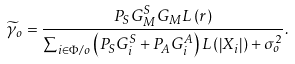Convert formula to latex. <formula><loc_0><loc_0><loc_500><loc_500>{ \widetilde { \gamma } _ { o } } = \frac { { { P _ { S } } G _ { M } ^ { S } G _ { M } L \left ( r \right ) } } { { \sum \nolimits _ { i \in \Phi / o } \left ( P _ { S } G _ { i } ^ { S } + P _ { A } G _ { i } ^ { A } \right ) L \left ( \left | X _ { i } \right | \right ) + { \sigma _ { o } ^ { 2 } } } } .</formula> 